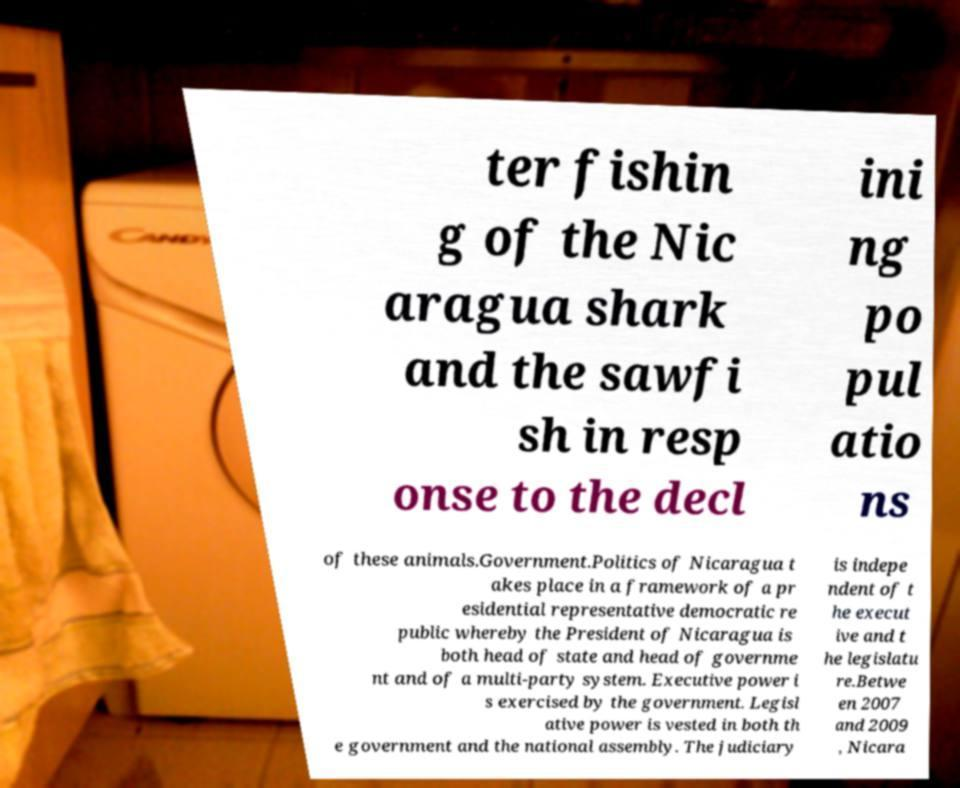What messages or text are displayed in this image? I need them in a readable, typed format. ter fishin g of the Nic aragua shark and the sawfi sh in resp onse to the decl ini ng po pul atio ns of these animals.Government.Politics of Nicaragua t akes place in a framework of a pr esidential representative democratic re public whereby the President of Nicaragua is both head of state and head of governme nt and of a multi-party system. Executive power i s exercised by the government. Legisl ative power is vested in both th e government and the national assembly. The judiciary is indepe ndent of t he execut ive and t he legislatu re.Betwe en 2007 and 2009 , Nicara 